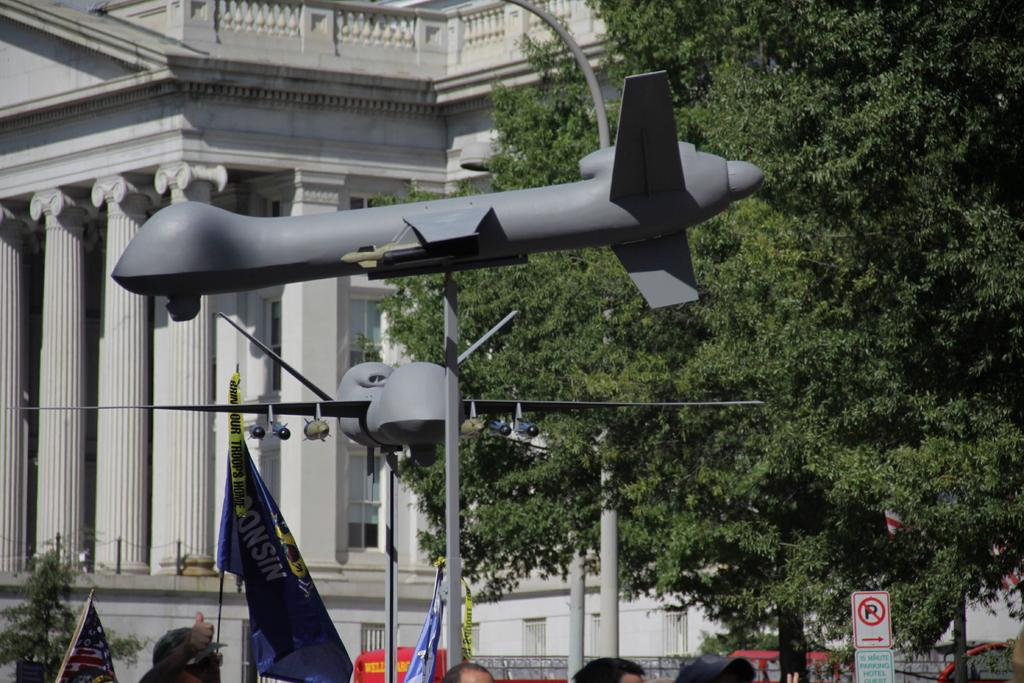What type of structure is present in the image? There is a building in the image. What architectural features can be seen on the building? There are windows visible on the building. What natural elements are present in the image? There are plants and trees in the image. What man-made objects are present in the image? There are flags, poles, and sign boards in the image. What type of toys can be seen in the image? There are aircraft toys in the image. Can you identify any human presence in the image? Yes, there are people's heads visible in the image. What type of chicken is depicted on the sign board in the image? There is no chicken present on any sign board in the image. What religious symbols can be seen in the image? There are no religious symbols visible in the image. Can you describe the brain activity of the people in the image? There is no information about the brain activity of the people in the image, as we can only see their heads. 